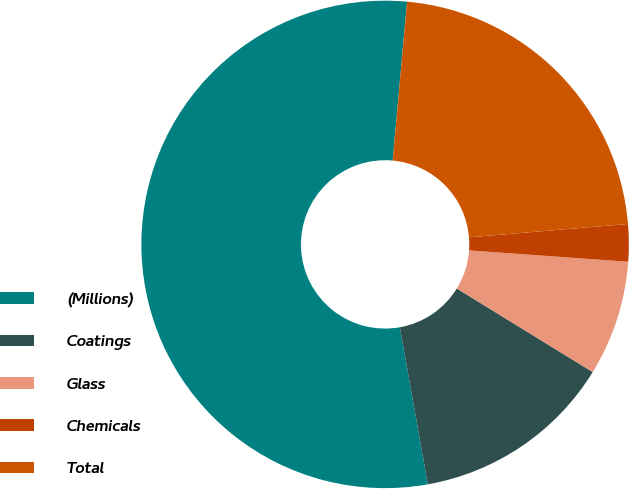Convert chart to OTSL. <chart><loc_0><loc_0><loc_500><loc_500><pie_chart><fcel>(Millions)<fcel>Coatings<fcel>Glass<fcel>Chemicals<fcel>Total<nl><fcel>54.24%<fcel>13.42%<fcel>7.64%<fcel>2.47%<fcel>22.23%<nl></chart> 